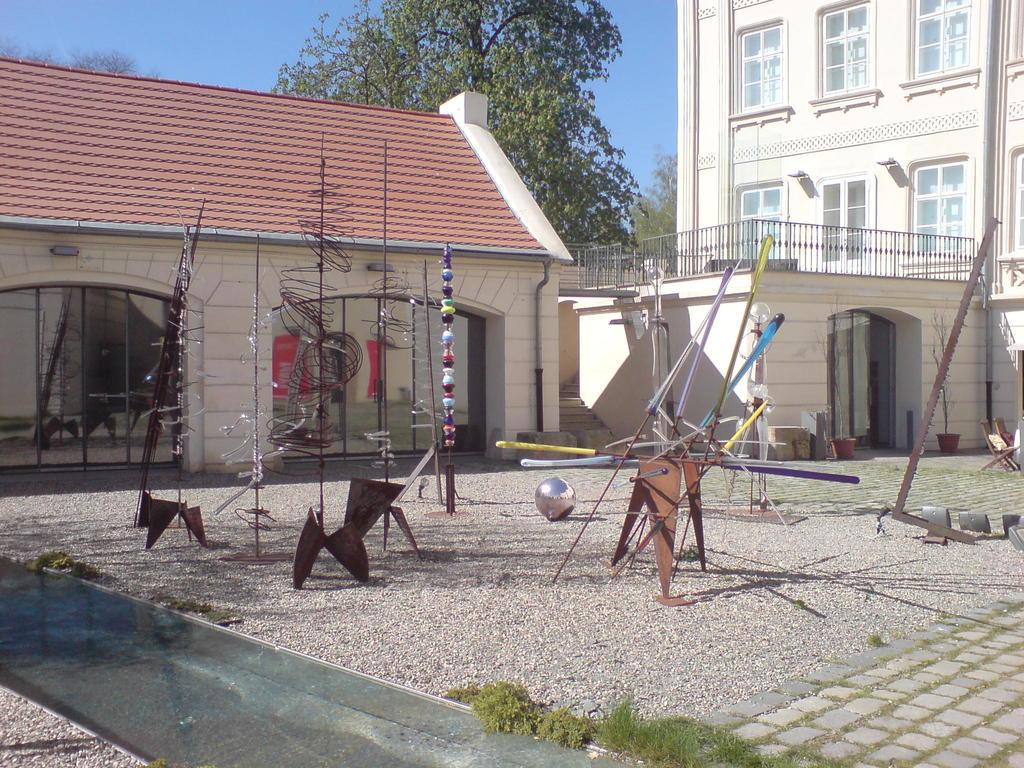Can you describe this image briefly? In this picture we can see sticks and some objects on the ground, here we can see house plants, buildings and we can see trees, sky in the background. 